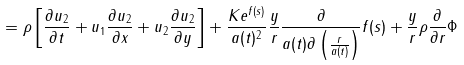Convert formula to latex. <formula><loc_0><loc_0><loc_500><loc_500>= \rho \left [ \frac { \partial u _ { 2 } } { \partial t } + u _ { 1 } \frac { \partial u _ { 2 } } { \partial x } + u _ { 2 } \frac { \partial u _ { 2 } } { \partial y } \right ] + \frac { K e ^ { f ( s ) } } { a ( t ) ^ { 2 } } \frac { y } { r } \frac { \partial } { a ( t ) \partial \left ( \frac { r } { a ( t ) } \right ) } f ( s ) + \frac { y } { r } \rho \frac { \partial } { \partial r } \Phi</formula> 